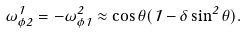Convert formula to latex. <formula><loc_0><loc_0><loc_500><loc_500>\omega { _ { \phi 2 } ^ { 1 } } = - \omega { _ { \phi 1 } ^ { 2 } } \approx \cos \theta ( 1 - \delta \sin ^ { 2 } \theta ) .</formula> 